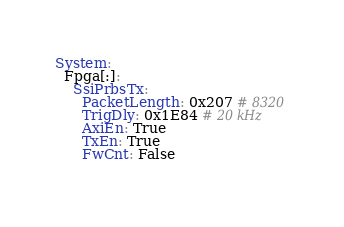Convert code to text. <code><loc_0><loc_0><loc_500><loc_500><_YAML_>System:
  Fpga[:]:
    SsiPrbsTx:
      PacketLength: 0x207 # 8320
      TrigDly: 0x1E84 # 20 kHz
      AxiEn: True
      TxEn: True
      FwCnt: False
      </code> 